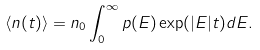Convert formula to latex. <formula><loc_0><loc_0><loc_500><loc_500>\langle n ( t ) \rangle = n _ { 0 } \int _ { 0 } ^ { \infty } p ( E ) \exp ( | E | t ) d E .</formula> 